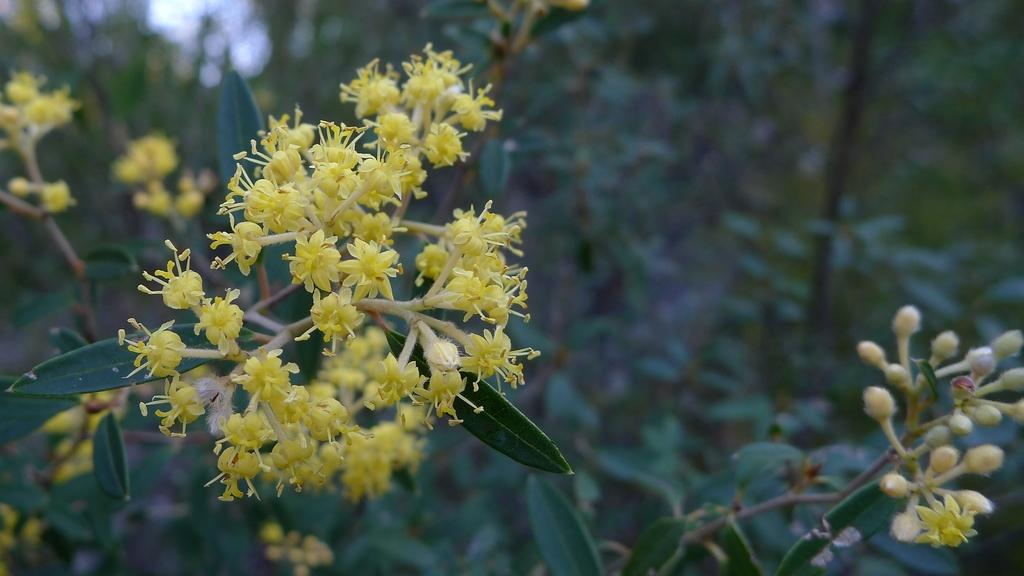What type of plants can be seen in the image? There are flowers, buds, and green leaves in the image. Can you describe the stage of growth for the plants in the image? The plants in the image have both buds and flowers, indicating different stages of growth. What is the background of the image like? The background of the image is blurred. What type of dinosaur can be seen in the image? There are no dinosaurs present in the image; it features plants with flowers, buds, and green leaves. Can you tell me which ear is visible in the image? There are no ears present in the image, as it features plants and not living beings with ears. 